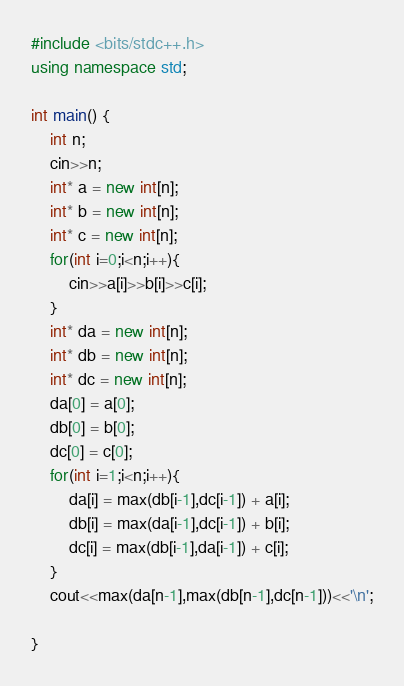<code> <loc_0><loc_0><loc_500><loc_500><_C++_>#include <bits/stdc++.h>
using namespace std;

int main() {
	int n;
	cin>>n;
	int* a = new int[n];
	int* b = new int[n];
	int* c = new int[n];
	for(int i=0;i<n;i++){
	    cin>>a[i]>>b[i]>>c[i];
	}
	int* da = new int[n];
	int* db = new int[n];
	int* dc = new int[n];
	da[0] = a[0];
	db[0] = b[0];
	dc[0] = c[0];
	for(int i=1;i<n;i++){
	    da[i] = max(db[i-1],dc[i-1]) + a[i];
	    db[i] = max(da[i-1],dc[i-1]) + b[i];
	    dc[i] = max(db[i-1],da[i-1]) + c[i];
	}
	cout<<max(da[n-1],max(db[n-1],dc[n-1]))<<'\n';

}
</code> 